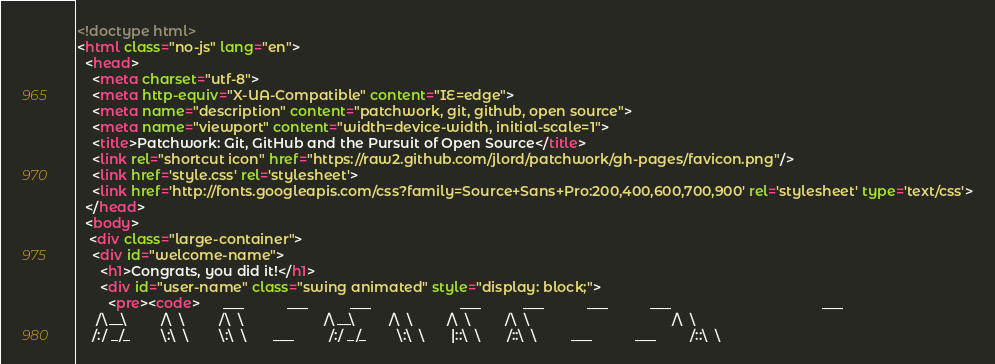Convert code to text. <code><loc_0><loc_0><loc_500><loc_500><_HTML_><!doctype html>
<html class="no-js" lang="en">
  <head>
    <meta charset="utf-8">
    <meta http-equiv="X-UA-Compatible" content="IE=edge">
    <meta name="description" content="patchwork, git, github, open source">
    <meta name="viewport" content="width=device-width, initial-scale=1">
    <title>Patchwork: Git, GitHub and the Pursuit of Open Source</title>
    <link rel="shortcut icon" href="https://raw2.github.com/jlord/patchwork/gh-pages/favicon.png"/>
    <link href='style.css' rel='stylesheet'>
    <link href='http://fonts.googleapis.com/css?family=Source+Sans+Pro:200,400,600,700,900' rel='stylesheet' type='text/css'>
  </head>
  <body>
   <div class="large-container">
    <div id="welcome-name">
      <h1>Congrats, you did it!</h1>
      <div id="user-name" class="swing animated" style="display: block;">
        <pre><code>      ___           ___           ___                       ___           ___           ___           ___                                       ___     
     /\__\         /\  \         /\  \                     /\__\         /\  \         /\  \         /\  \                                     /\  \    
    /:/ _/_        \:\  \        \:\  \       ___         /:/ _/_        \:\  \       |::\  \       /::\  \         ___           ___         /::\  \   </code> 